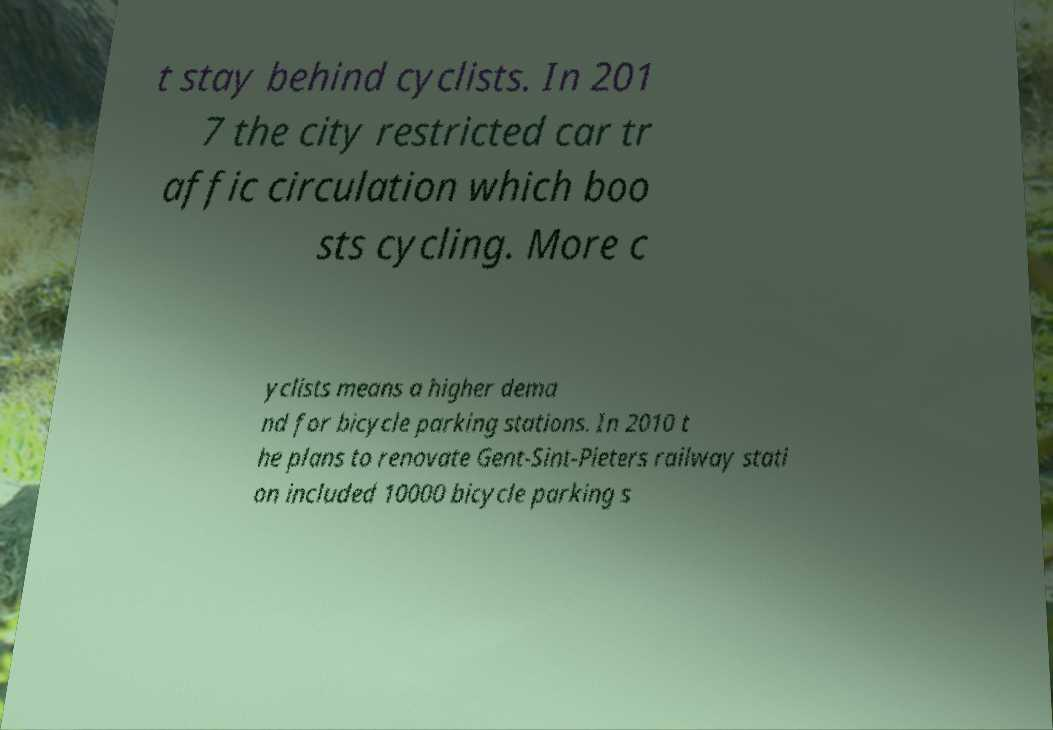Please identify and transcribe the text found in this image. t stay behind cyclists. In 201 7 the city restricted car tr affic circulation which boo sts cycling. More c yclists means a higher dema nd for bicycle parking stations. In 2010 t he plans to renovate Gent-Sint-Pieters railway stati on included 10000 bicycle parking s 